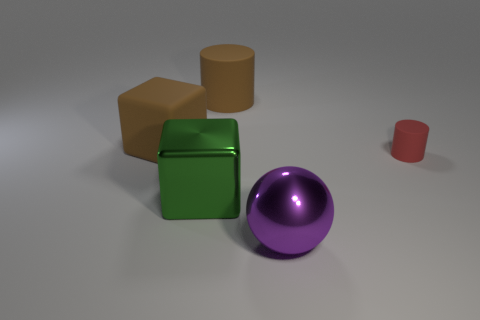Imagine these objects were part of an abstract art piece. What could they symbolize? If these objects were part of an abstract art piece, they could symbolize a variety of concepts. The different geometric shapes might represent diversity and the uniqueness of individuals within a community. The green cube's reflective surface could symbolize clarity and perception, while the matte surfaces of the brown cube and tan cylinder might denote groundedness and stability. The purple sphere's perfect roundness could be a symbol of wholeness and unity. And the small red cylinder might represent the small yet significant elements that complete the bigger picture. The overall arrangement could portray a harmonious coexistence of distinct parts within a larger whole. 